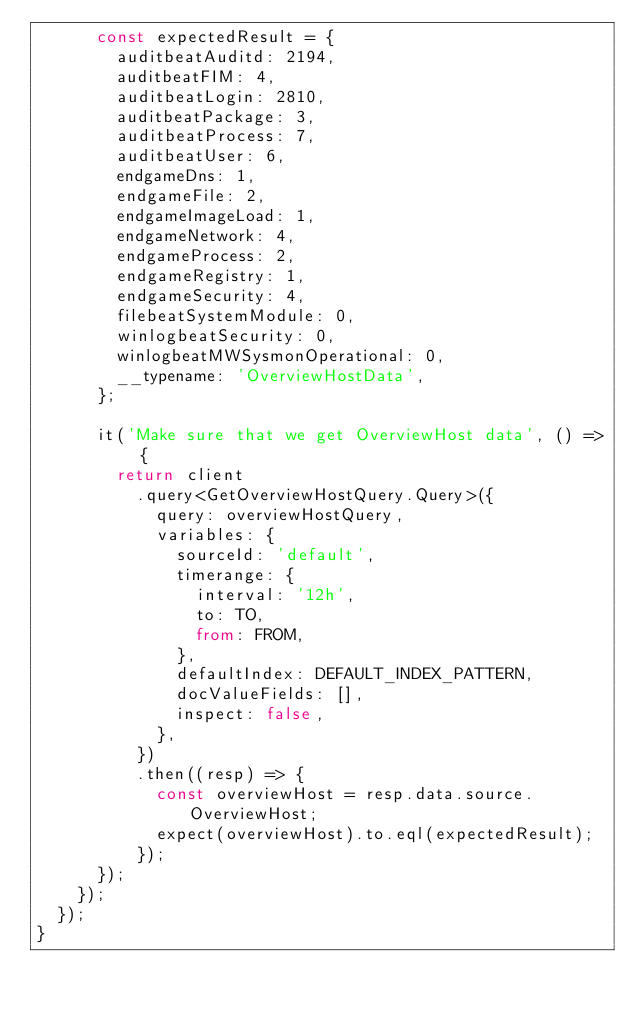<code> <loc_0><loc_0><loc_500><loc_500><_TypeScript_>      const expectedResult = {
        auditbeatAuditd: 2194,
        auditbeatFIM: 4,
        auditbeatLogin: 2810,
        auditbeatPackage: 3,
        auditbeatProcess: 7,
        auditbeatUser: 6,
        endgameDns: 1,
        endgameFile: 2,
        endgameImageLoad: 1,
        endgameNetwork: 4,
        endgameProcess: 2,
        endgameRegistry: 1,
        endgameSecurity: 4,
        filebeatSystemModule: 0,
        winlogbeatSecurity: 0,
        winlogbeatMWSysmonOperational: 0,
        __typename: 'OverviewHostData',
      };

      it('Make sure that we get OverviewHost data', () => {
        return client
          .query<GetOverviewHostQuery.Query>({
            query: overviewHostQuery,
            variables: {
              sourceId: 'default',
              timerange: {
                interval: '12h',
                to: TO,
                from: FROM,
              },
              defaultIndex: DEFAULT_INDEX_PATTERN,
              docValueFields: [],
              inspect: false,
            },
          })
          .then((resp) => {
            const overviewHost = resp.data.source.OverviewHost;
            expect(overviewHost).to.eql(expectedResult);
          });
      });
    });
  });
}
</code> 